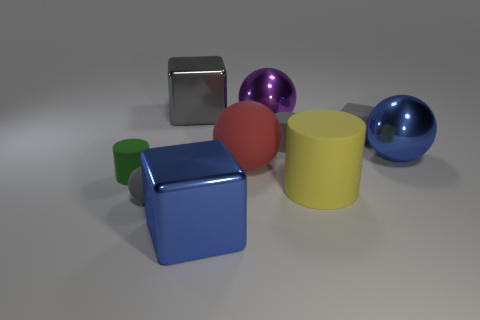How many gray blocks must be subtracted to get 1 gray blocks? 1 Subtract all cubes. How many objects are left? 7 Subtract 1 red spheres. How many objects are left? 9 Subtract all gray metallic balls. Subtract all big purple objects. How many objects are left? 9 Add 4 small matte spheres. How many small matte spheres are left? 5 Add 10 large brown metal spheres. How many large brown metal spheres exist? 10 